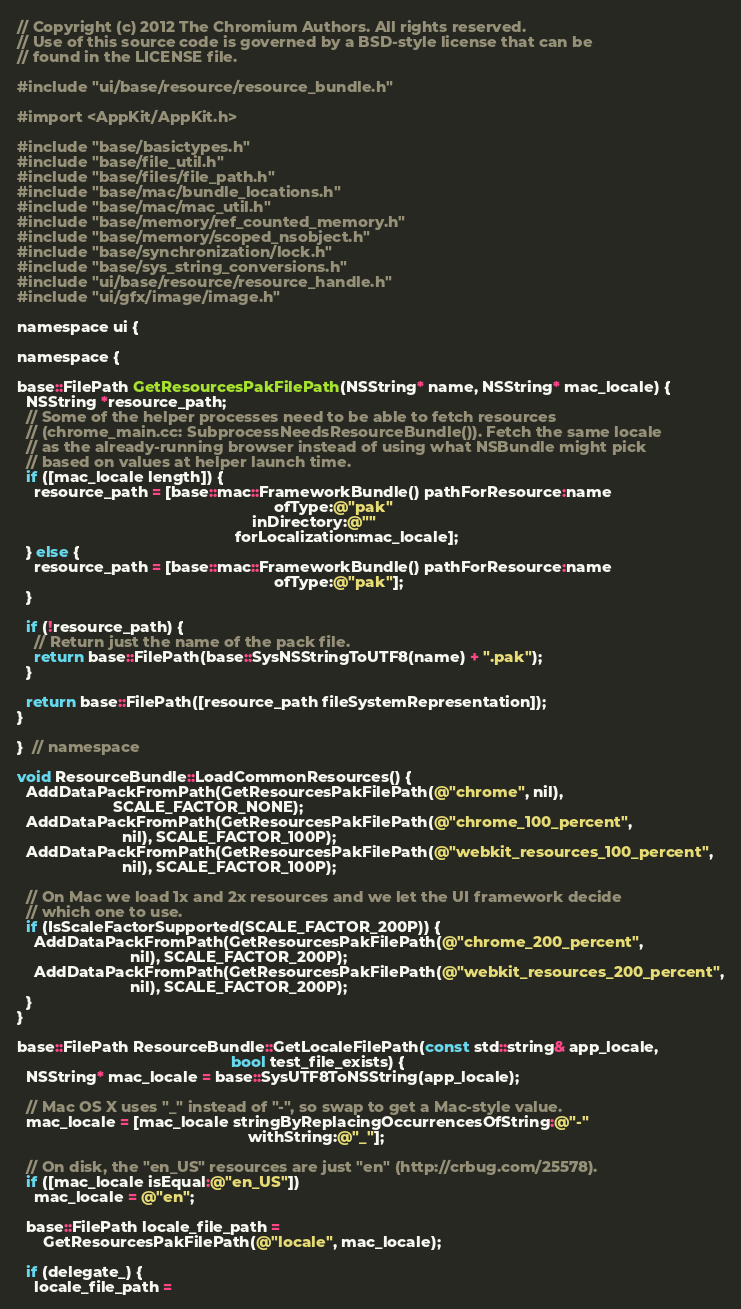Convert code to text. <code><loc_0><loc_0><loc_500><loc_500><_ObjectiveC_>// Copyright (c) 2012 The Chromium Authors. All rights reserved.
// Use of this source code is governed by a BSD-style license that can be
// found in the LICENSE file.

#include "ui/base/resource/resource_bundle.h"

#import <AppKit/AppKit.h>

#include "base/basictypes.h"
#include "base/file_util.h"
#include "base/files/file_path.h"
#include "base/mac/bundle_locations.h"
#include "base/mac/mac_util.h"
#include "base/memory/ref_counted_memory.h"
#include "base/memory/scoped_nsobject.h"
#include "base/synchronization/lock.h"
#include "base/sys_string_conversions.h"
#include "ui/base/resource/resource_handle.h"
#include "ui/gfx/image/image.h"

namespace ui {

namespace {

base::FilePath GetResourcesPakFilePath(NSString* name, NSString* mac_locale) {
  NSString *resource_path;
  // Some of the helper processes need to be able to fetch resources
  // (chrome_main.cc: SubprocessNeedsResourceBundle()). Fetch the same locale
  // as the already-running browser instead of using what NSBundle might pick
  // based on values at helper launch time.
  if ([mac_locale length]) {
    resource_path = [base::mac::FrameworkBundle() pathForResource:name
                                                           ofType:@"pak"
                                                      inDirectory:@""
                                                  forLocalization:mac_locale];
  } else {
    resource_path = [base::mac::FrameworkBundle() pathForResource:name
                                                           ofType:@"pak"];
  }

  if (!resource_path) {
    // Return just the name of the pack file.
    return base::FilePath(base::SysNSStringToUTF8(name) + ".pak");
  }

  return base::FilePath([resource_path fileSystemRepresentation]);
}

}  // namespace

void ResourceBundle::LoadCommonResources() {
  AddDataPackFromPath(GetResourcesPakFilePath(@"chrome", nil),
                      SCALE_FACTOR_NONE);
  AddDataPackFromPath(GetResourcesPakFilePath(@"chrome_100_percent",
                        nil), SCALE_FACTOR_100P);
  AddDataPackFromPath(GetResourcesPakFilePath(@"webkit_resources_100_percent",
                        nil), SCALE_FACTOR_100P);

  // On Mac we load 1x and 2x resources and we let the UI framework decide
  // which one to use.
  if (IsScaleFactorSupported(SCALE_FACTOR_200P)) {
    AddDataPackFromPath(GetResourcesPakFilePath(@"chrome_200_percent",
                          nil), SCALE_FACTOR_200P);
    AddDataPackFromPath(GetResourcesPakFilePath(@"webkit_resources_200_percent",
                          nil), SCALE_FACTOR_200P);
  }
}

base::FilePath ResourceBundle::GetLocaleFilePath(const std::string& app_locale,
                                                 bool test_file_exists) {
  NSString* mac_locale = base::SysUTF8ToNSString(app_locale);

  // Mac OS X uses "_" instead of "-", so swap to get a Mac-style value.
  mac_locale = [mac_locale stringByReplacingOccurrencesOfString:@"-"
                                                     withString:@"_"];

  // On disk, the "en_US" resources are just "en" (http://crbug.com/25578).
  if ([mac_locale isEqual:@"en_US"])
    mac_locale = @"en";

  base::FilePath locale_file_path =
      GetResourcesPakFilePath(@"locale", mac_locale);

  if (delegate_) {
    locale_file_path =</code> 